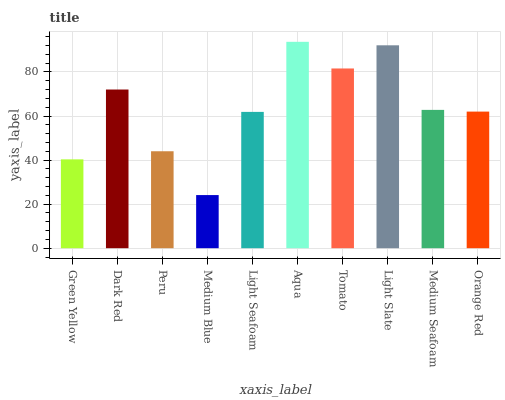Is Medium Blue the minimum?
Answer yes or no. Yes. Is Aqua the maximum?
Answer yes or no. Yes. Is Dark Red the minimum?
Answer yes or no. No. Is Dark Red the maximum?
Answer yes or no. No. Is Dark Red greater than Green Yellow?
Answer yes or no. Yes. Is Green Yellow less than Dark Red?
Answer yes or no. Yes. Is Green Yellow greater than Dark Red?
Answer yes or no. No. Is Dark Red less than Green Yellow?
Answer yes or no. No. Is Medium Seafoam the high median?
Answer yes or no. Yes. Is Orange Red the low median?
Answer yes or no. Yes. Is Aqua the high median?
Answer yes or no. No. Is Medium Seafoam the low median?
Answer yes or no. No. 